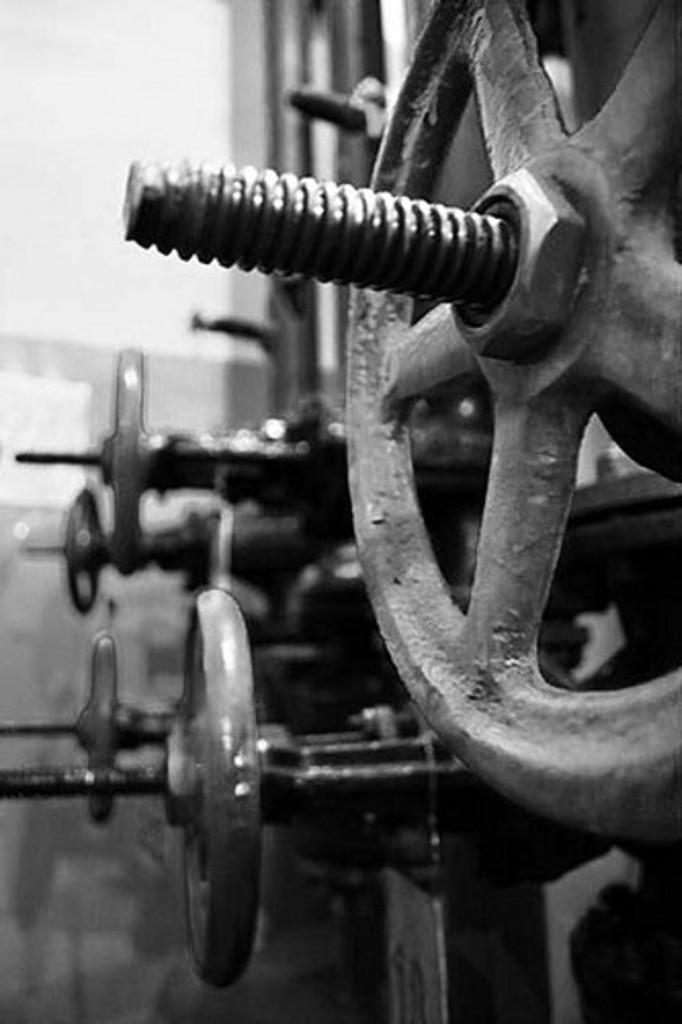What type of objects are present in the image? There are machine tools in the image. Can you describe the background of the image? The background of the image is blurred. Where is the kitten playing with a collar in the image? There is no kitten or collar present in the image; it features machine tools and a blurred background. 